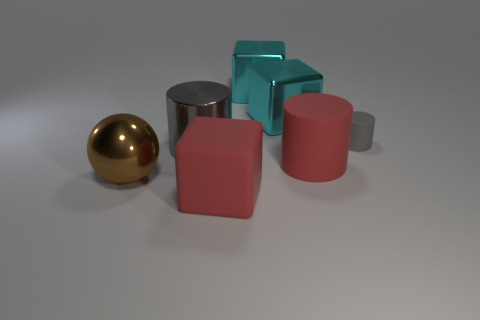What number of other gray things are the same shape as the tiny gray thing?
Keep it short and to the point. 1. There is a gray object that is left of the red rubber cylinder that is on the right side of the large gray cylinder; what is it made of?
Your answer should be very brief. Metal. There is a big thing that is the same color as the tiny rubber cylinder; what is its shape?
Ensure brevity in your answer.  Cylinder. Are there any red spheres made of the same material as the big brown ball?
Offer a terse response. No. The tiny matte object has what shape?
Provide a short and direct response. Cylinder. How many green blocks are there?
Offer a very short reply. 0. There is a large object left of the gray cylinder left of the small gray matte object; what color is it?
Your response must be concise. Brown. There is a matte cylinder that is the same size as the metal ball; what is its color?
Provide a short and direct response. Red. Is there another object of the same color as the tiny object?
Ensure brevity in your answer.  Yes. Are there any red cubes?
Provide a short and direct response. Yes. 